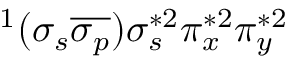<formula> <loc_0><loc_0><loc_500><loc_500>^ { 1 } ( \sigma _ { s } \overline { { \sigma _ { p } } } ) \sigma _ { s } ^ { * 2 } \pi _ { x } ^ { * 2 } \pi _ { y } ^ { * 2 }</formula> 